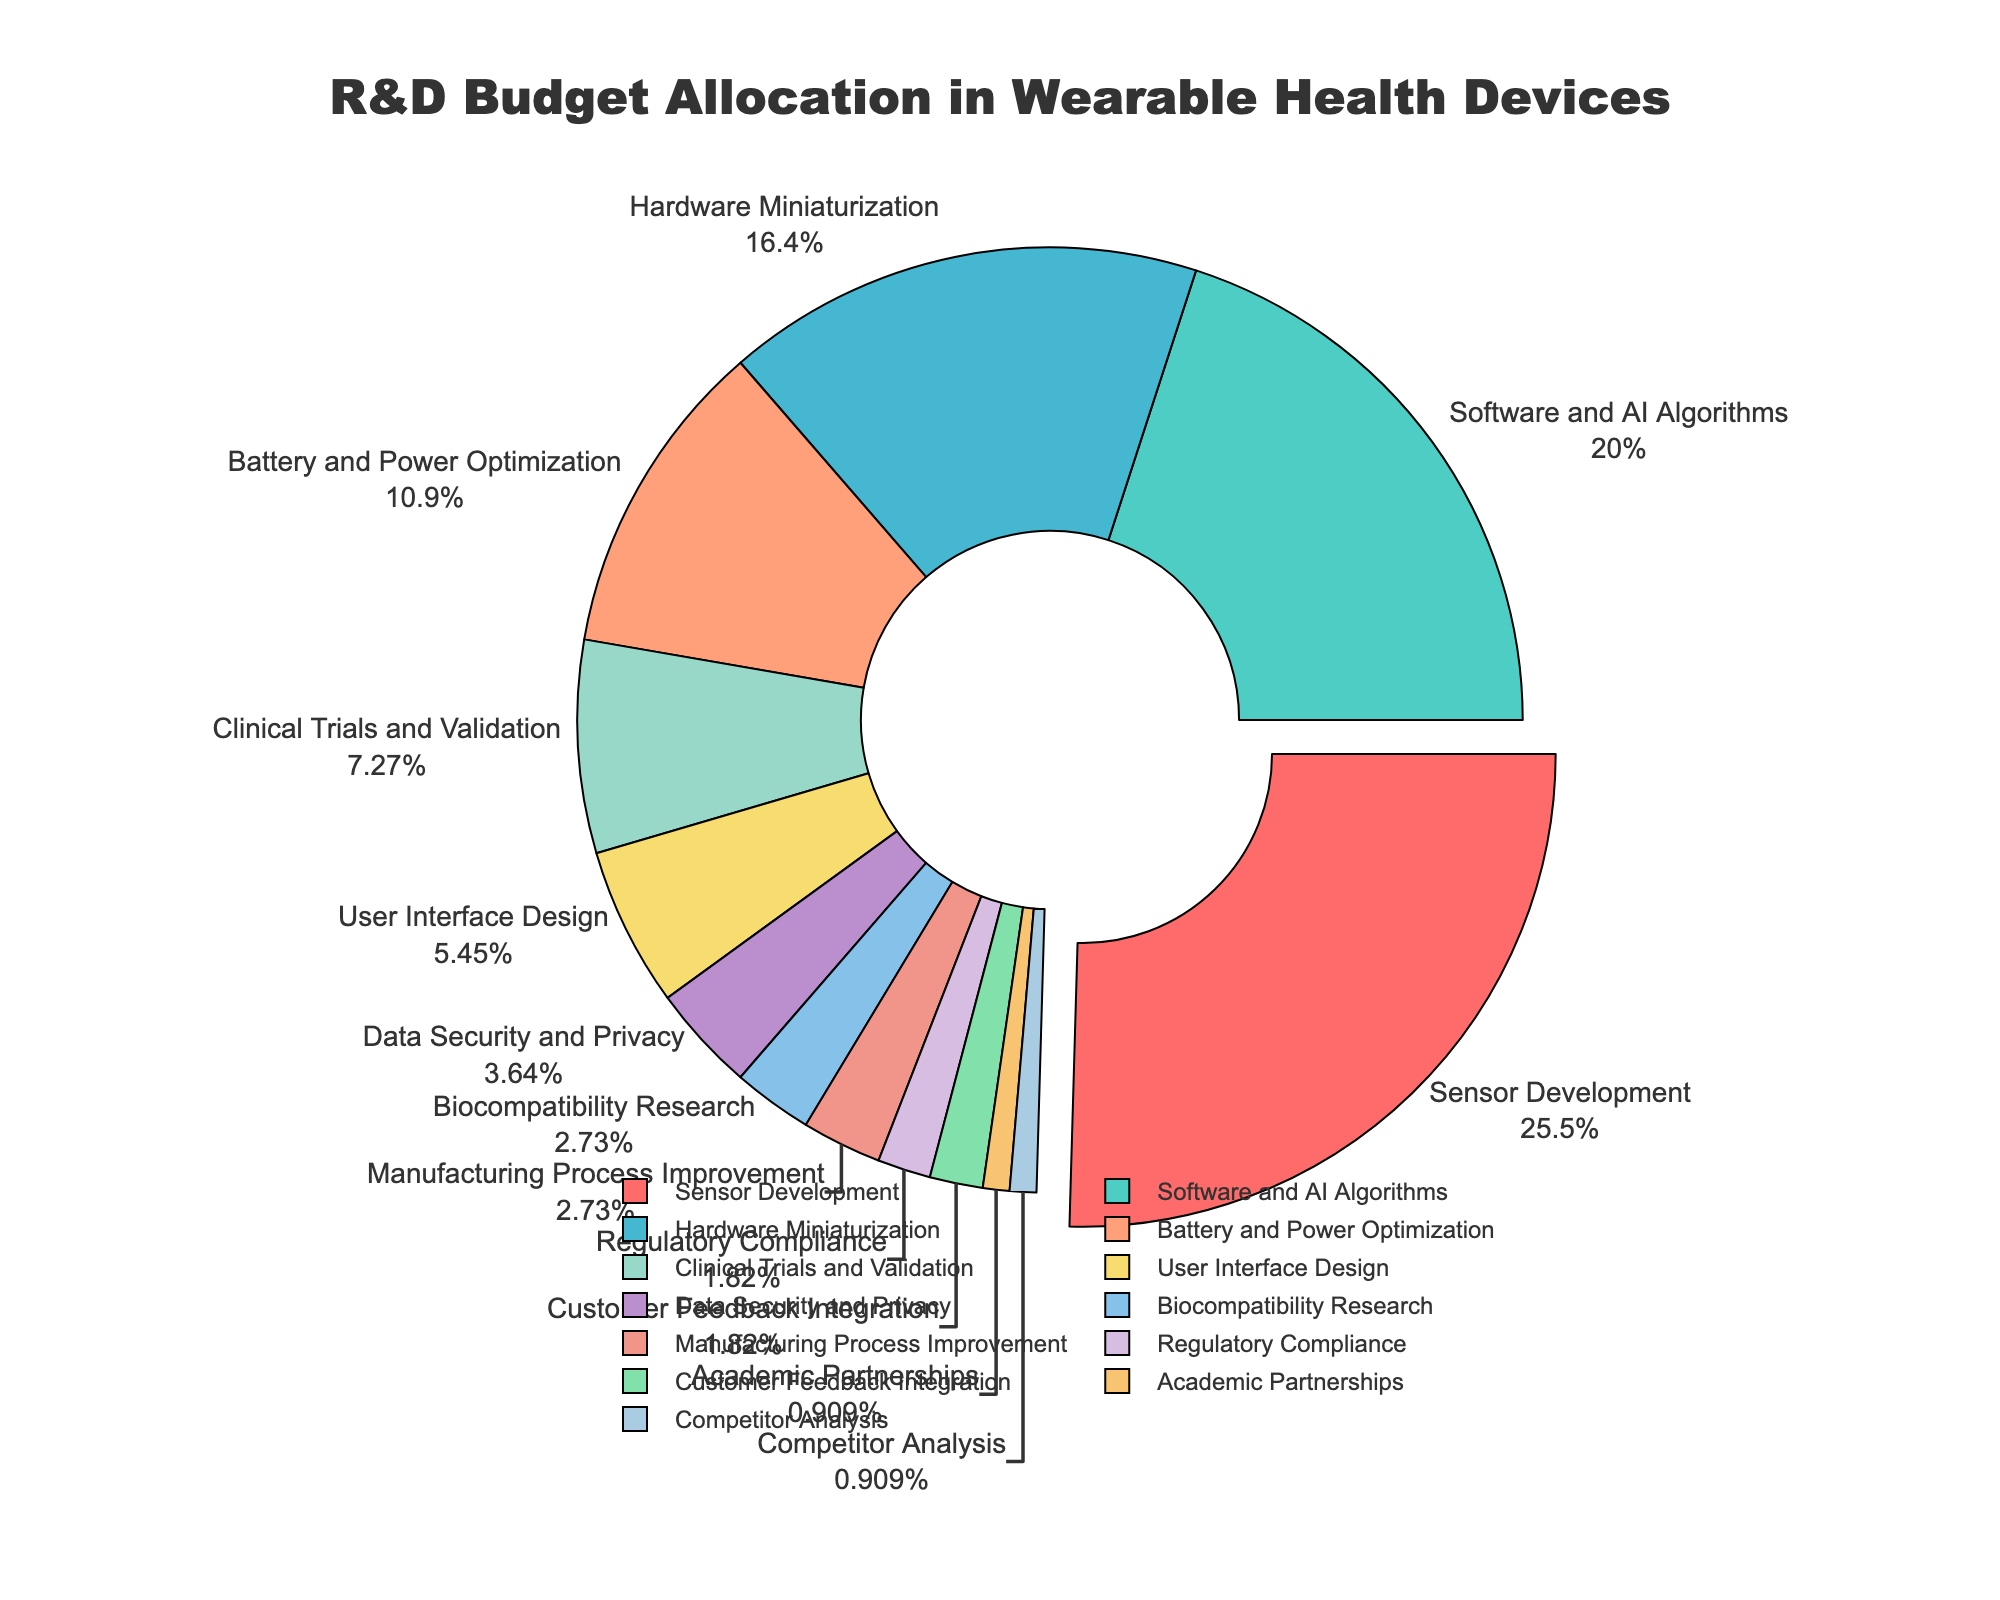Which category received the largest portion of the R&D budget? The figure shows a pie chart with percentages for each category. The largest portion can be identified by the size of the slice, which is labeled "Sensor Development" with 28%.
Answer: Sensor Development How much more is allocated to Sensor Development compared to Battery and Power Optimization? Look for the percentage values for both Sensor Development and Battery and Power Optimization. Sensor Development is 28% and Battery and Power Optimization is 12%. Subtract the smaller value from the larger value to find the difference: 28% - 12% = 16%.
Answer: 16% What is the combined percentage allocated to Software and AI Algorithms and Hardware Miniaturization? Check the pie chart for the percentages of Software and AI Algorithms and Hardware Miniaturization. They are 22% and 18% respectively. Adding these two values gives: 22% + 18% = 40%.
Answer: 40% Which two categories together have the smallest allocation, and what is their combined percentage? Identify the two smallest slices on the pie chart. Regulatory Compliance and Customer Feedback Integration both have the smallest percentages at 2% each. Their combined percentage is: 2% + 2% = 4%.
Answer: Regulatory Compliance and Customer Feedback Integration, 4% What portion of the R&D budget is allocated to categories related to power and battery optimization combined with user interface design? Find the percentages for Battery and Power Optimization (12%) and User Interface Design (6%). Add these values: 12% + 6% = 18%.
Answer: 18% Which category has a smaller budget allocation: Data Security and Privacy or Biocompatibility Research? Check the pie chart for the percentages of Data Security and Privacy (4%) and Biocompatibility Research (3%). The smaller percentage is Biocompatibility Research at 3%.
Answer: Biocompatibility Research How does the allocation for Clinical Trials and Validation compare to the allocation for Data Security and Privacy? Find the percentages for Clinical Trials and Validation (8%) and Data Security and Privacy (4%). Compare them. Clinical Trials and Validation has a higher allocation with 8% as compared to 4% for Data Security and Privacy.
Answer: Clinical Trials and Validation If you combine the allocations for Academic Partnerships and Competitor Analysis, how does their total compare to the allocation for Clinical Trials and Validation? Look at the percentages for Academic Partnerships (1%) and Competitor Analysis (1%). Their combined total is: 1% + 1% = 2%. Compare this to Clinical Trials and Validation at 8%. 2% is less than 8%.
Answer: Less What is the total percentage allocated to the categories that received less than 5% each? Identify the categories with less than 5%. They are: Biocompatibility Research (3%), Manufacturing Process Improvement (3%), Regulatory Compliance (2%), Customer Feedback Integration (2%), Academic Partnerships (1%), and Competitor Analysis (1%). Sum these values: 3% + 3% + 2% + 2% + 1% + 1% = 12%.
Answer: 12% 